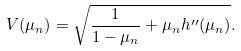<formula> <loc_0><loc_0><loc_500><loc_500>V ( \mu _ { n } ) = \sqrt { \frac { 1 } { 1 - \mu _ { n } } + \mu _ { n } h ^ { \prime \prime } ( \mu _ { n } ) } .</formula> 